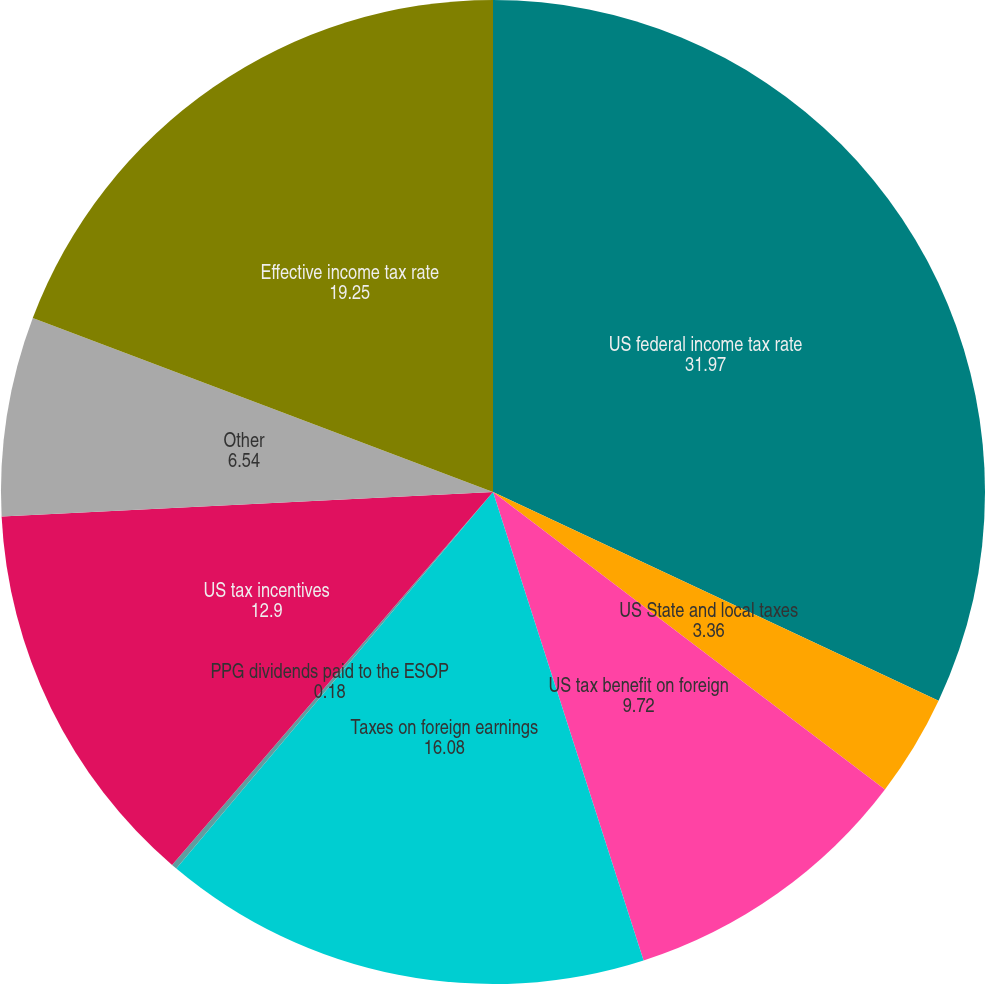Convert chart. <chart><loc_0><loc_0><loc_500><loc_500><pie_chart><fcel>US federal income tax rate<fcel>US State and local taxes<fcel>US tax benefit on foreign<fcel>Taxes on foreign earnings<fcel>PPG dividends paid to the ESOP<fcel>US tax incentives<fcel>Other<fcel>Effective income tax rate<nl><fcel>31.97%<fcel>3.36%<fcel>9.72%<fcel>16.08%<fcel>0.18%<fcel>12.9%<fcel>6.54%<fcel>19.25%<nl></chart> 